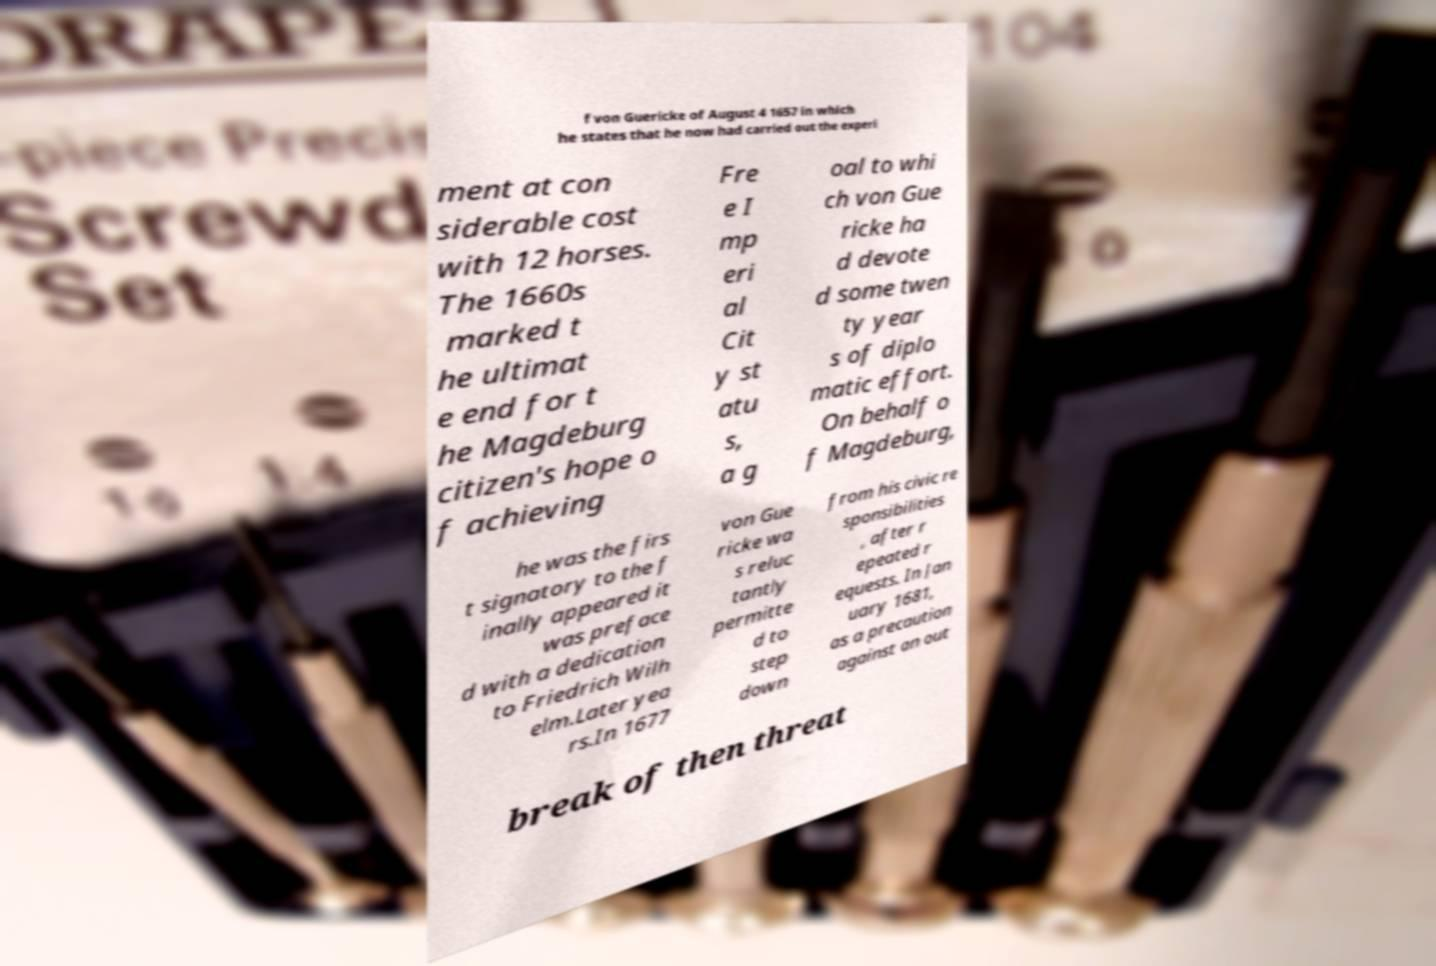Please read and relay the text visible in this image. What does it say? f von Guericke of August 4 1657 in which he states that he now had carried out the experi ment at con siderable cost with 12 horses. The 1660s marked t he ultimat e end for t he Magdeburg citizen's hope o f achieving Fre e I mp eri al Cit y st atu s, a g oal to whi ch von Gue ricke ha d devote d some twen ty year s of diplo matic effort. On behalf o f Magdeburg, he was the firs t signatory to the f inally appeared it was preface d with a dedication to Friedrich Wilh elm.Later yea rs.In 1677 von Gue ricke wa s reluc tantly permitte d to step down from his civic re sponsibilities , after r epeated r equests. In Jan uary 1681, as a precaution against an out break of then threat 